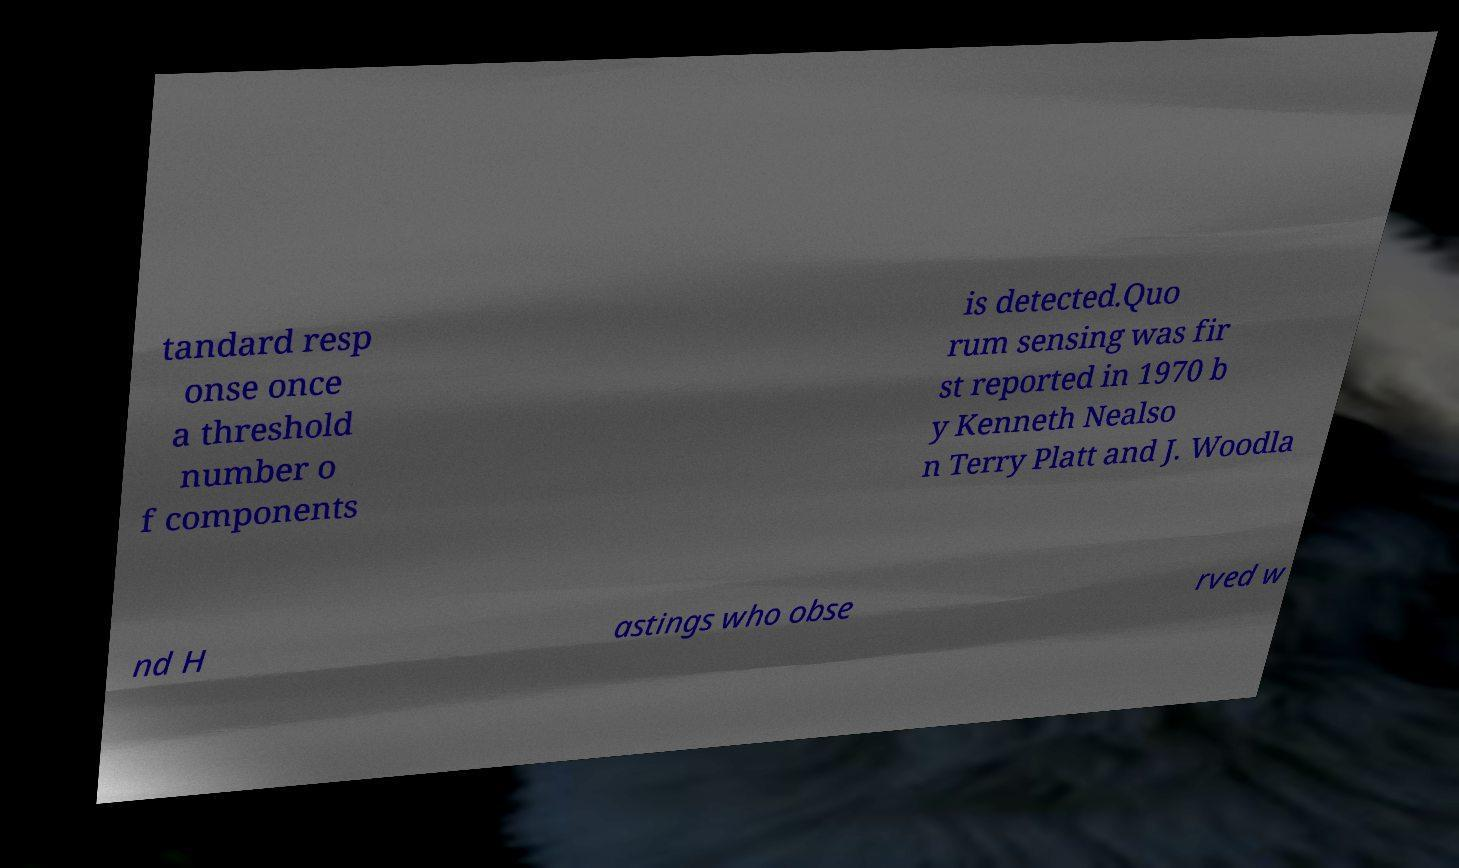What messages or text are displayed in this image? I need them in a readable, typed format. tandard resp onse once a threshold number o f components is detected.Quo rum sensing was fir st reported in 1970 b y Kenneth Nealso n Terry Platt and J. Woodla nd H astings who obse rved w 